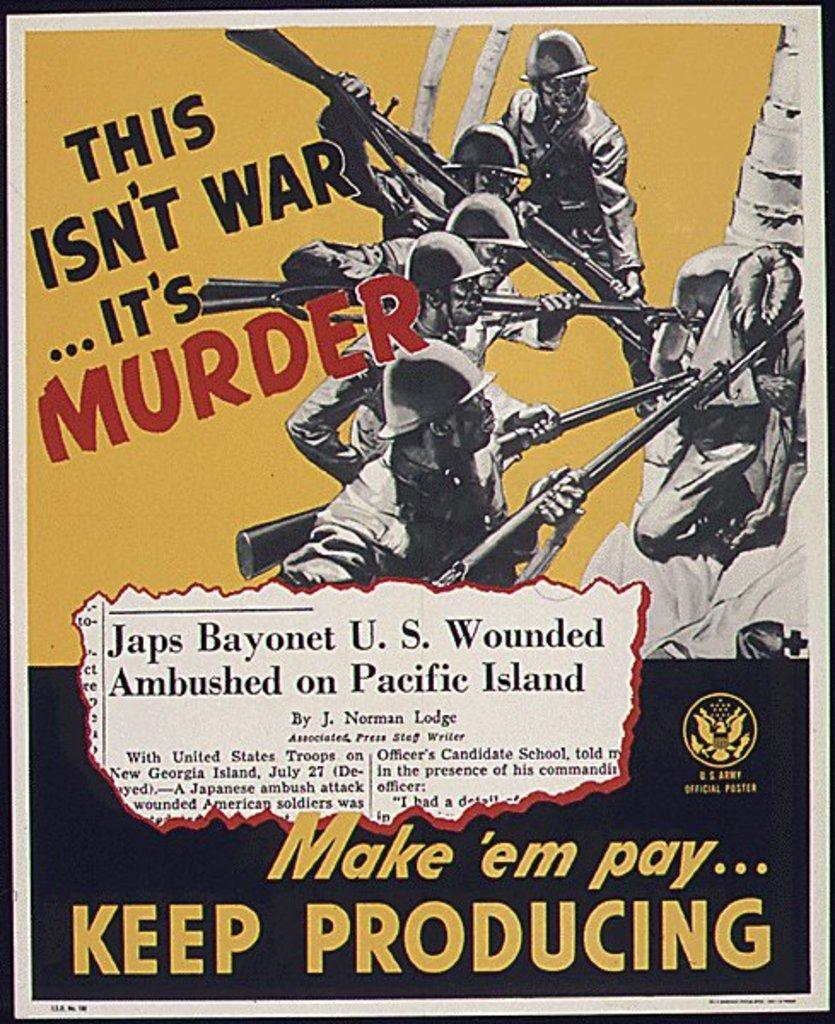<image>
Present a compact description of the photo's key features. Poster that says "Make em pay" on the bottom. 